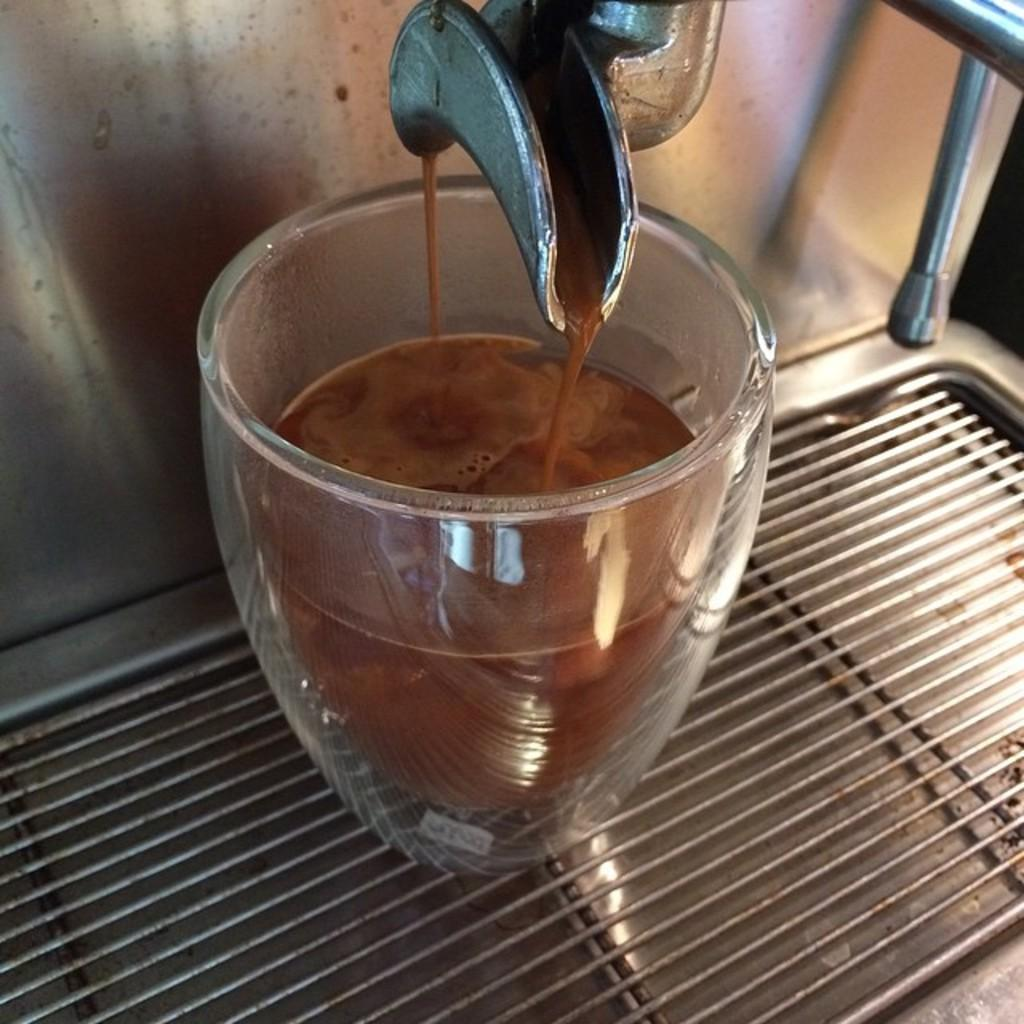What appliance is present in the image? There is a coffee machine in the image. What feature does the coffee machine have? The coffee machine has an outlet. What is the coffee machine doing in the image? Coffee is flowing from the coffee machine. What is happening to the coffee as it flows from the machine? There is a glass being filled with coffee in the image. What type of army is depicted in the image? There is no army present in the image; it features a coffee machine and a glass being filled with coffee. How many ants can be seen carrying coffee beans in the image? There are no ants present in the image, and therefore no such activity can be observed. 